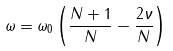<formula> <loc_0><loc_0><loc_500><loc_500>\omega = \omega _ { 0 } \left ( \frac { N + 1 } { N } - \frac { 2 \nu } { N } \right )</formula> 